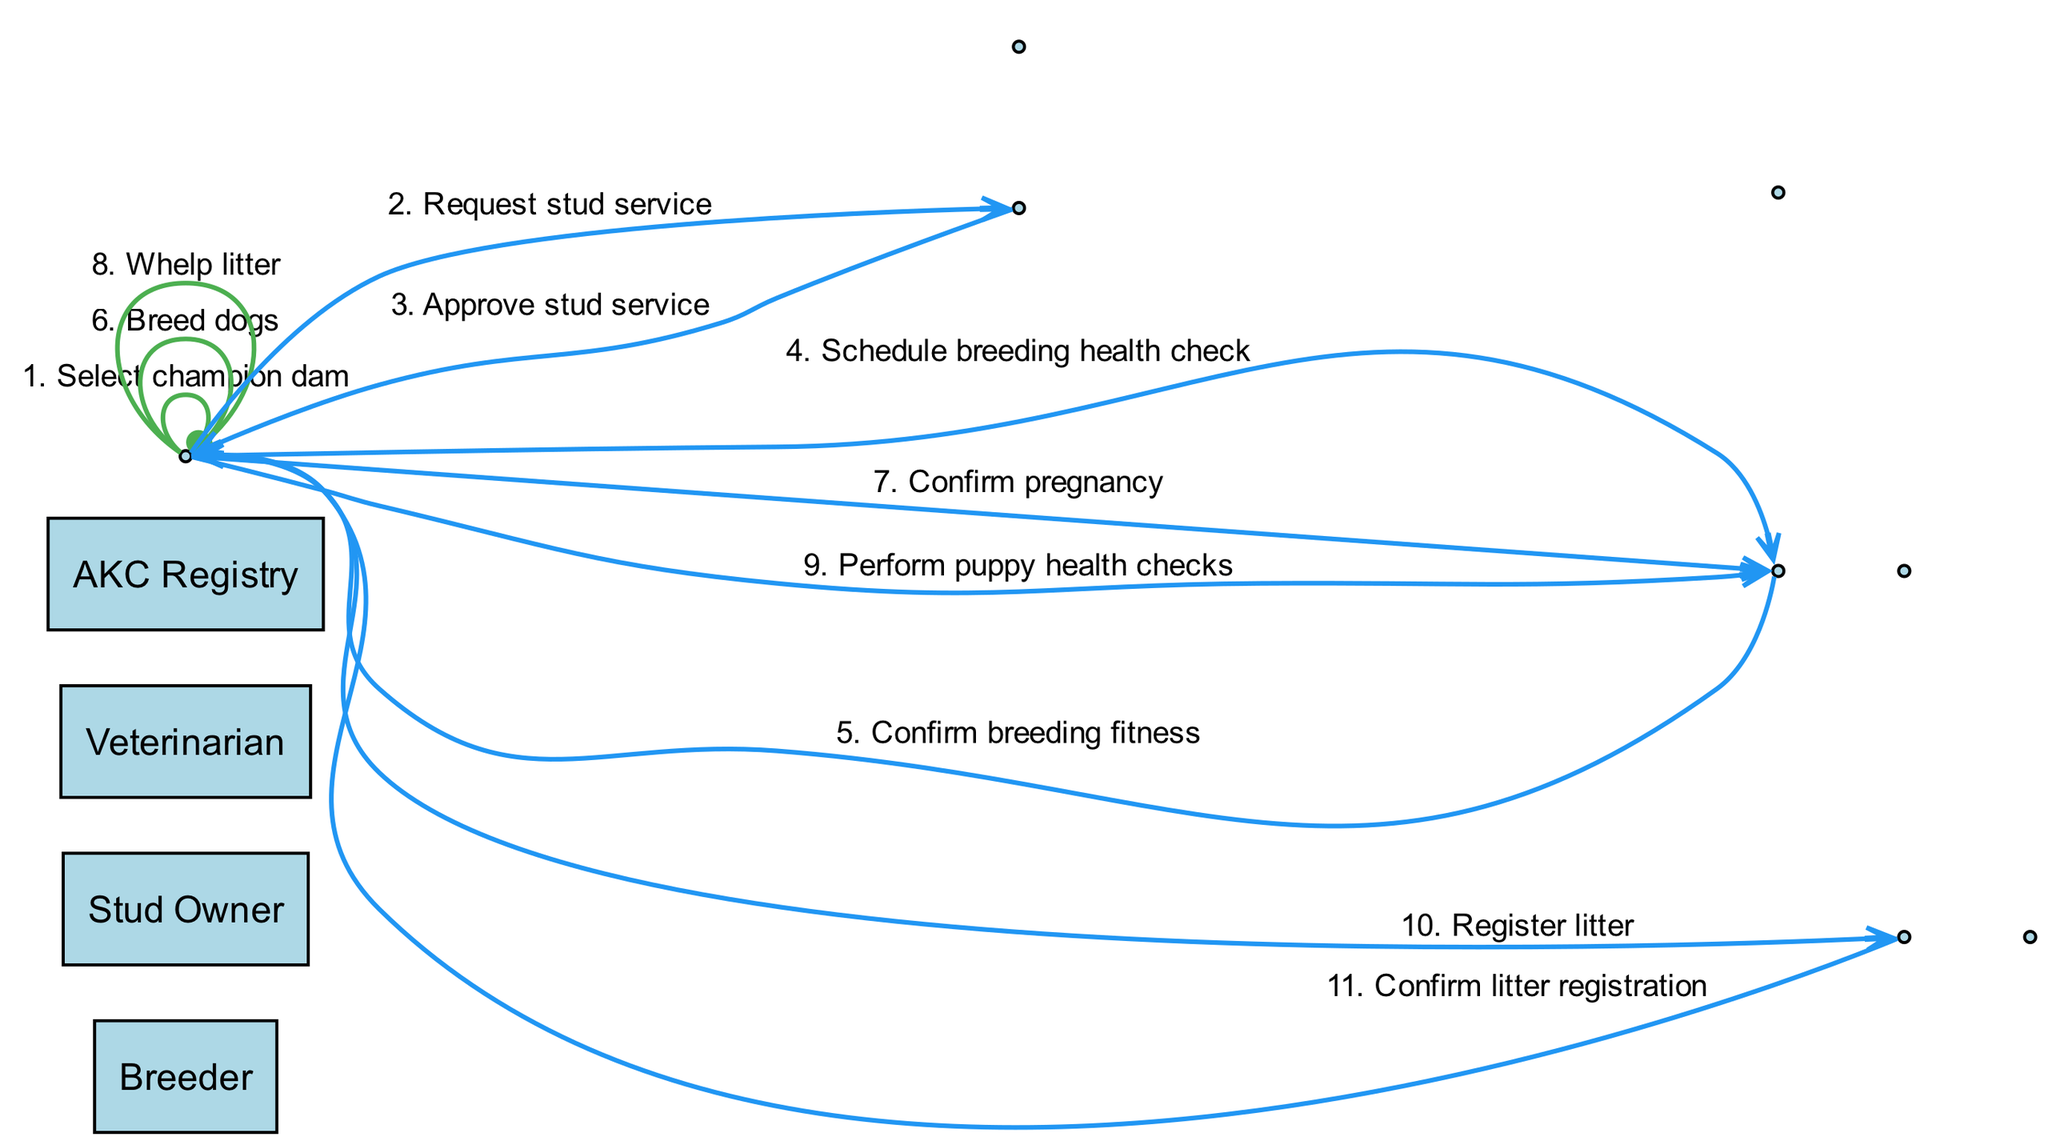What is the first action performed in the breeding process? The first action listed in the sequence is "Select champion dam," which is performed by the Breeder.
Answer: Select champion dam How many unique actors are involved in the breeding process? The diagram lists four unique actors: Breeder, Stud Owner, Veterinarian, and AKC Registry.
Answer: Four Who is responsible for confirming the breeding fitness? The Veterinarian is responsible for confirming the breeding fitness after the Breeder schedules a health check.
Answer: Veterinarian What action follows the confirmation of pregnancy? After the confirmation of pregnancy, the next action is "Whelp litter," performed by the Breeder.
Answer: Whelp litter What is the final action in the breeding process? The last action in the sequence is "Confirm litter registration," done by the AKC Registry.
Answer: Confirm litter registration How many actions are performed by the Breeder in this sequence? The Breeder performs five actions: Select champion dam, Request stud service, Breed dogs, Whelp litter, and Register litter.
Answer: Five Which two actors are directly involved in the action of "Request stud service"? The Breeder requests the stud service from the Stud Owner, so these two actors are involved.
Answer: Breeder, Stud Owner What action is taken after the litter is whelped? After whelping the litter, the next action is "Perform puppy health checks," which involves the Breeder consulting the Veterinarian.
Answer: Perform puppy health checks What is the relationship between the action of "Approve stud service" and the previous action? The action of "Approve stud service" follows "Request stud service" as a confirmation from the Stud Owner to the Breeder.
Answer: Confirmation 